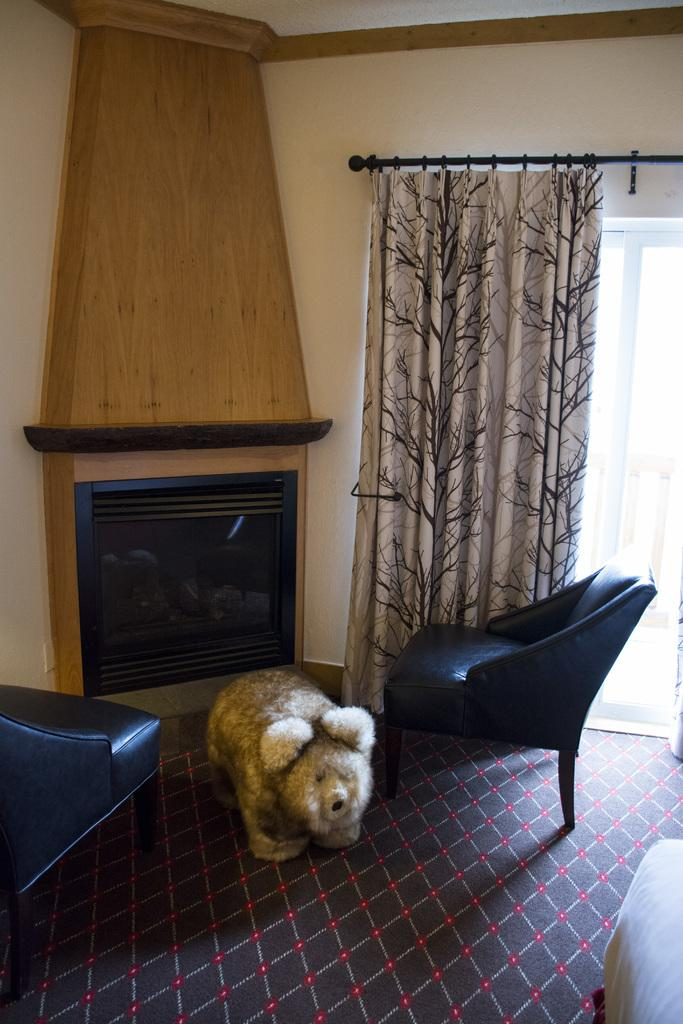How many chairs are visible in the image? There are 2 chairs in the image. What type of animal is present in the image? There is a dog in the image. What is the background of the image? There is a wall in the image. Can you describe the window in the image? There is a window in the image, and it has a curtain associated with it. What type of pig can be seen playing with the governor in the image? There is no pig or governor present in the image; it features 2 chairs, a dog, a wall, a window, and a curtain. How many babies are visible in the image? There are no babies present in the image. 